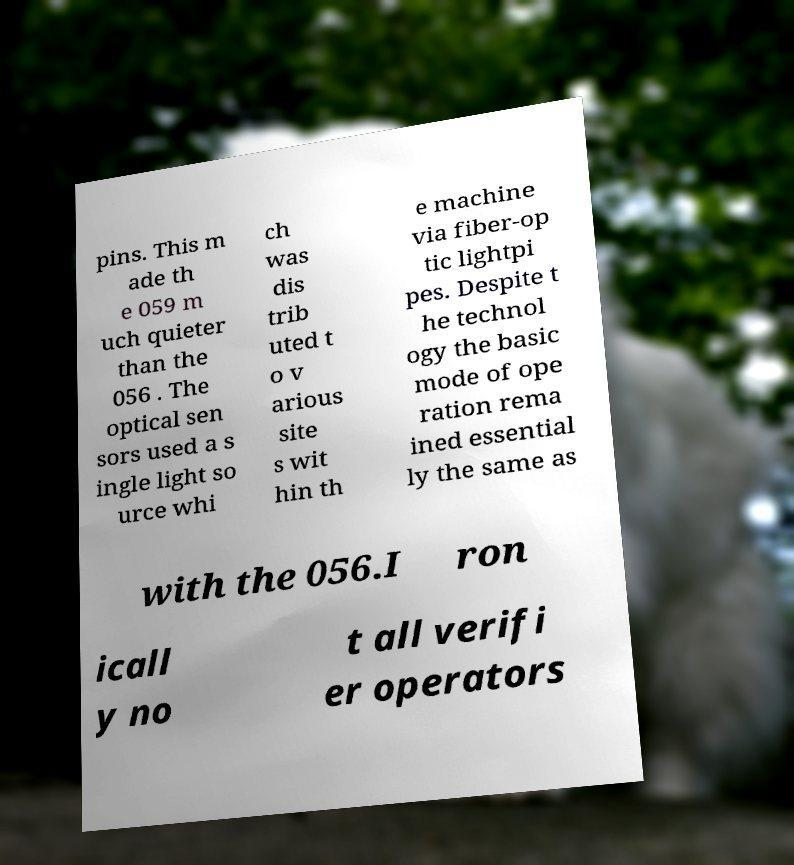I need the written content from this picture converted into text. Can you do that? pins. This m ade th e 059 m uch quieter than the 056 . The optical sen sors used a s ingle light so urce whi ch was dis trib uted t o v arious site s wit hin th e machine via fiber-op tic lightpi pes. Despite t he technol ogy the basic mode of ope ration rema ined essential ly the same as with the 056.I ron icall y no t all verifi er operators 